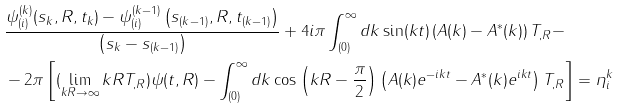<formula> <loc_0><loc_0><loc_500><loc_500>& \frac { \psi _ { ( i ) } ^ { ( k ) } ( s _ { k } , R , t _ { k } ) - \psi _ { ( i ) } ^ { ( k - 1 ) } \left ( s _ { ( k - 1 ) } , R , t _ { ( k - 1 ) } \right ) } { \left ( s _ { k } - s _ { ( k - 1 ) } \right ) } + 4 i \pi \int _ { ( 0 ) } ^ { \infty } d k \sin ( k t ) \left ( A ( k ) - A ^ { * } ( k ) \right ) T _ { , R } - \\ & - 2 \pi \left [ ( \lim _ { k R \to \infty } k R T _ { , R } ) \psi ( t , R ) - \int _ { ( 0 ) } ^ { \infty } d k \cos \left ( k R - \frac { \pi } { 2 } \right ) \left ( A ( k ) e ^ { - i k t } - A ^ { * } ( k ) e ^ { i k t } \right ) T _ { , R } \right ] = \eta _ { i } ^ { k }</formula> 